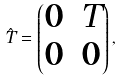Convert formula to latex. <formula><loc_0><loc_0><loc_500><loc_500>\hat { T } = \begin{pmatrix} 0 & T \\ 0 & 0 \end{pmatrix} ,</formula> 